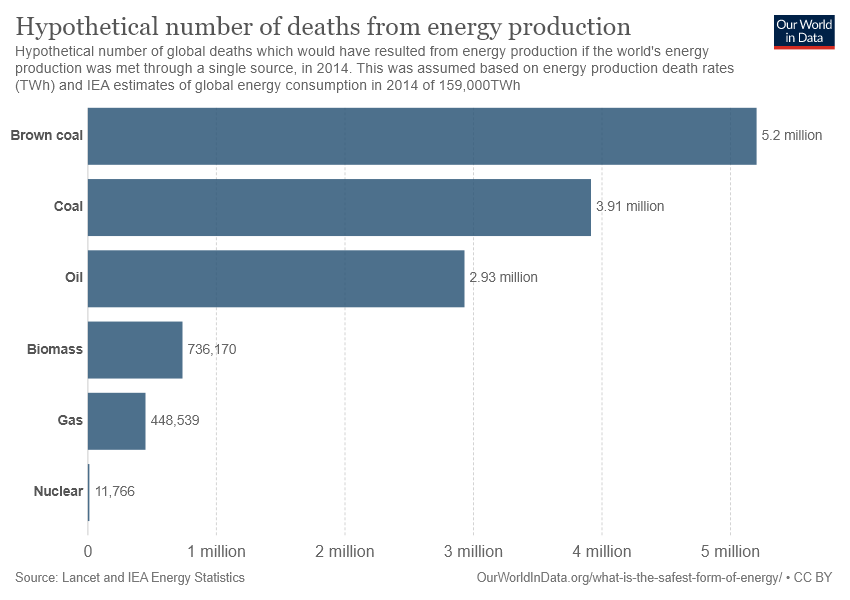Draw attention to some important aspects in this diagram. According to records, 5.2 people have died as a result of brown coal production. The difference between the number of deaths from biomass and gas production is 287,631. 